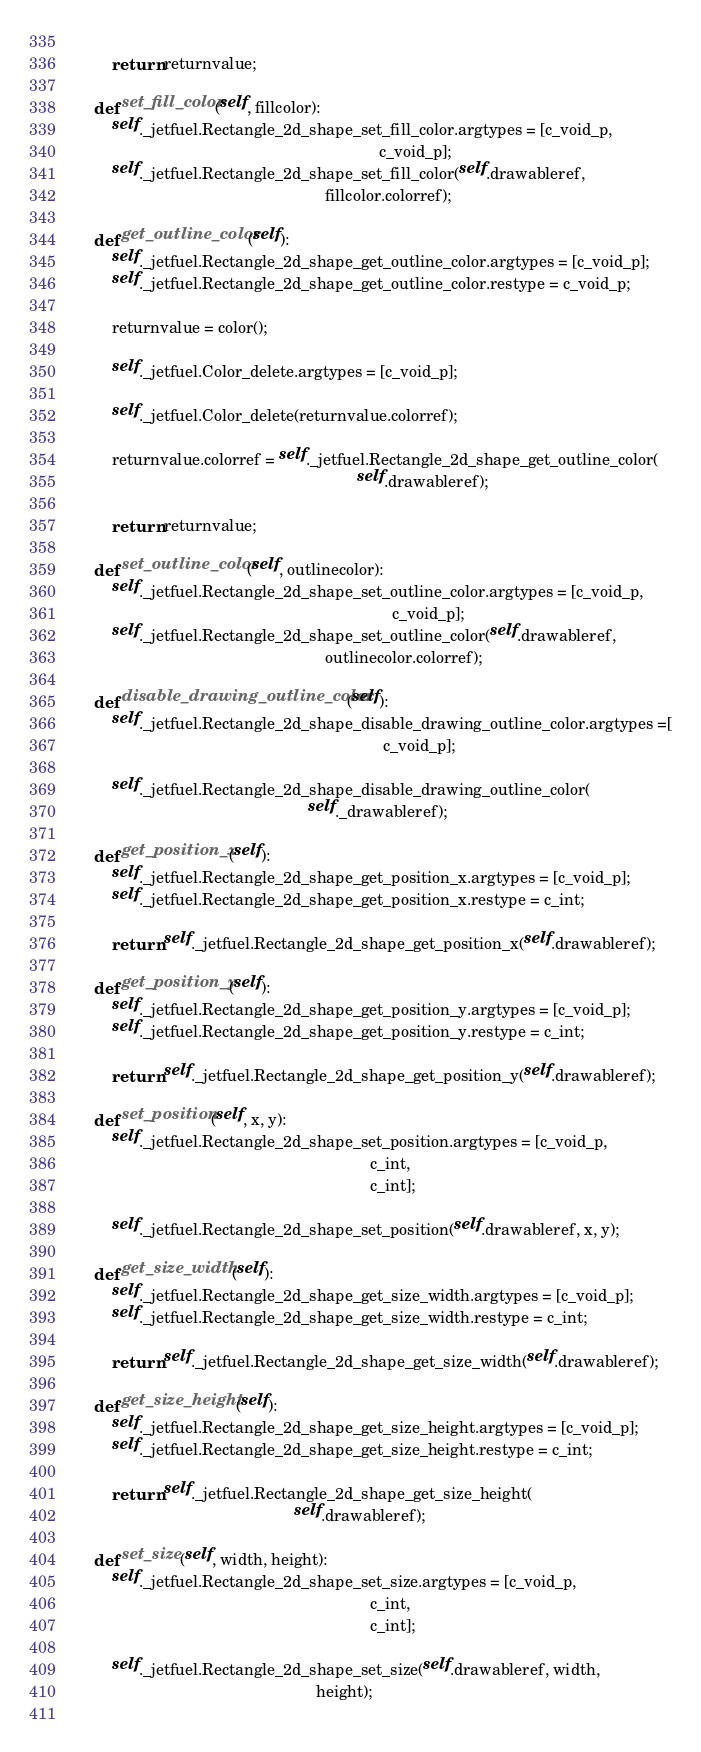Convert code to text. <code><loc_0><loc_0><loc_500><loc_500><_Python_>        
        return returnvalue;
    
    def set_fill_color(self, fillcolor):
        self._jetfuel.Rectangle_2d_shape_set_fill_color.argtypes = [c_void_p,
                                                                    c_void_p];
        self._jetfuel.Rectangle_2d_shape_set_fill_color(self.drawableref,
                                                        fillcolor.colorref);
                                                        
    def get_outline_color(self):
        self._jetfuel.Rectangle_2d_shape_get_outline_color.argtypes = [c_void_p];
        self._jetfuel.Rectangle_2d_shape_get_outline_color.restype = c_void_p;
        
        returnvalue = color();
        
        self._jetfuel.Color_delete.argtypes = [c_void_p];
        
        self._jetfuel.Color_delete(returnvalue.colorref);
        
        returnvalue.colorref = self._jetfuel.Rectangle_2d_shape_get_outline_color(
                                                               self.drawableref);
        
        return returnvalue;
    
    def set_outline_color(self, outlinecolor):
        self._jetfuel.Rectangle_2d_shape_set_outline_color.argtypes = [c_void_p,
                                                                       c_void_p];
        self._jetfuel.Rectangle_2d_shape_set_outline_color(self.drawableref,
                                                        outlinecolor.colorref);
                                                        
    def disable_drawing_outline_color(self):
        self._jetfuel.Rectangle_2d_shape_disable_drawing_outline_color.argtypes =[
                                                                     c_void_p];
        
        self._jetfuel.Rectangle_2d_shape_disable_drawing_outline_color(
                                                    self._drawableref);
                                                        
    def get_position_x(self):
        self._jetfuel.Rectangle_2d_shape_get_position_x.argtypes = [c_void_p];
        self._jetfuel.Rectangle_2d_shape_get_position_x.restype = c_int;
        
        return self._jetfuel.Rectangle_2d_shape_get_position_x(self.drawableref);
    
    def get_position_y(self):
        self._jetfuel.Rectangle_2d_shape_get_position_y.argtypes = [c_void_p];
        self._jetfuel.Rectangle_2d_shape_get_position_y.restype = c_int;
        
        return self._jetfuel.Rectangle_2d_shape_get_position_y(self.drawableref);
    
    def set_position(self, x, y):
        self._jetfuel.Rectangle_2d_shape_set_position.argtypes = [c_void_p, 
                                                                  c_int,
                                                                  c_int];
                                                                  
        self._jetfuel.Rectangle_2d_shape_set_position(self.drawableref, x, y);
        
    def get_size_width(self):
        self._jetfuel.Rectangle_2d_shape_get_size_width.argtypes = [c_void_p];
        self._jetfuel.Rectangle_2d_shape_get_size_width.restype = c_int;
        
        return self._jetfuel.Rectangle_2d_shape_get_size_width(self.drawableref);
    
    def get_size_height(self):
        self._jetfuel.Rectangle_2d_shape_get_size_height.argtypes = [c_void_p];
        self._jetfuel.Rectangle_2d_shape_get_size_height.restype = c_int;
        
        return self._jetfuel.Rectangle_2d_shape_get_size_height(
                                                 self.drawableref);
    
    def set_size(self, width, height):
        self._jetfuel.Rectangle_2d_shape_set_size.argtypes = [c_void_p, 
                                                                  c_int,
                                                                  c_int];
                                                                  
        self._jetfuel.Rectangle_2d_shape_set_size(self.drawableref, width, 
                                                      height);
        </code> 